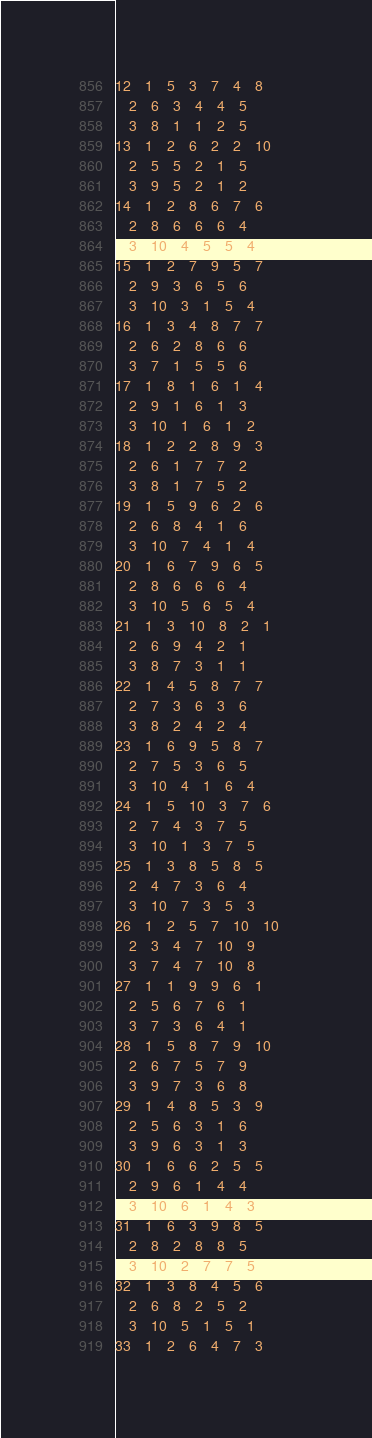<code> <loc_0><loc_0><loc_500><loc_500><_ObjectiveC_>12	1	5	3	7	4	8	
	2	6	3	4	4	5	
	3	8	1	1	2	5	
13	1	2	6	2	2	10	
	2	5	5	2	1	5	
	3	9	5	2	1	2	
14	1	2	8	6	7	6	
	2	8	6	6	6	4	
	3	10	4	5	5	4	
15	1	2	7	9	5	7	
	2	9	3	6	5	6	
	3	10	3	1	5	4	
16	1	3	4	8	7	7	
	2	6	2	8	6	6	
	3	7	1	5	5	6	
17	1	8	1	6	1	4	
	2	9	1	6	1	3	
	3	10	1	6	1	2	
18	1	2	2	8	9	3	
	2	6	1	7	7	2	
	3	8	1	7	5	2	
19	1	5	9	6	2	6	
	2	6	8	4	1	6	
	3	10	7	4	1	4	
20	1	6	7	9	6	5	
	2	8	6	6	6	4	
	3	10	5	6	5	4	
21	1	3	10	8	2	1	
	2	6	9	4	2	1	
	3	8	7	3	1	1	
22	1	4	5	8	7	7	
	2	7	3	6	3	6	
	3	8	2	4	2	4	
23	1	6	9	5	8	7	
	2	7	5	3	6	5	
	3	10	4	1	6	4	
24	1	5	10	3	7	6	
	2	7	4	3	7	5	
	3	10	1	3	7	5	
25	1	3	8	5	8	5	
	2	4	7	3	6	4	
	3	10	7	3	5	3	
26	1	2	5	7	10	10	
	2	3	4	7	10	9	
	3	7	4	7	10	8	
27	1	1	9	9	6	1	
	2	5	6	7	6	1	
	3	7	3	6	4	1	
28	1	5	8	7	9	10	
	2	6	7	5	7	9	
	3	9	7	3	6	8	
29	1	4	8	5	3	9	
	2	5	6	3	1	6	
	3	9	6	3	1	3	
30	1	6	6	2	5	5	
	2	9	6	1	4	4	
	3	10	6	1	4	3	
31	1	6	3	9	8	5	
	2	8	2	8	8	5	
	3	10	2	7	7	5	
32	1	3	8	4	5	6	
	2	6	8	2	5	2	
	3	10	5	1	5	1	
33	1	2	6	4	7	3	</code> 